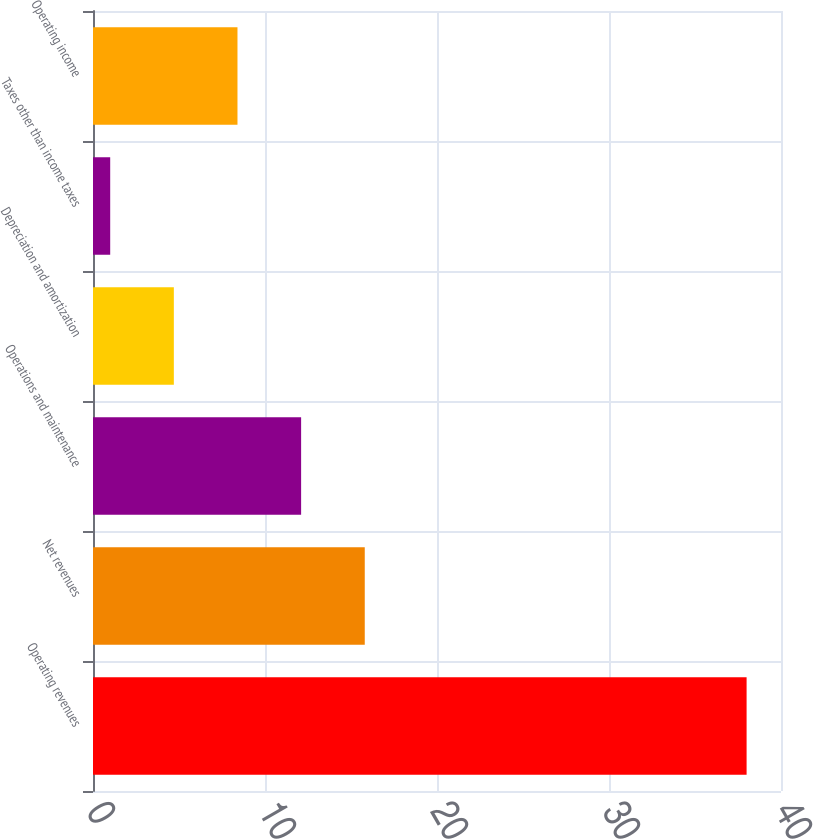<chart> <loc_0><loc_0><loc_500><loc_500><bar_chart><fcel>Operating revenues<fcel>Net revenues<fcel>Operations and maintenance<fcel>Depreciation and amortization<fcel>Taxes other than income taxes<fcel>Operating income<nl><fcel>38<fcel>15.8<fcel>12.1<fcel>4.7<fcel>1<fcel>8.4<nl></chart> 